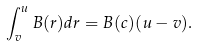Convert formula to latex. <formula><loc_0><loc_0><loc_500><loc_500>\int _ { v } ^ { u } B ( r ) d r = B ( c ) ( u - v ) .</formula> 